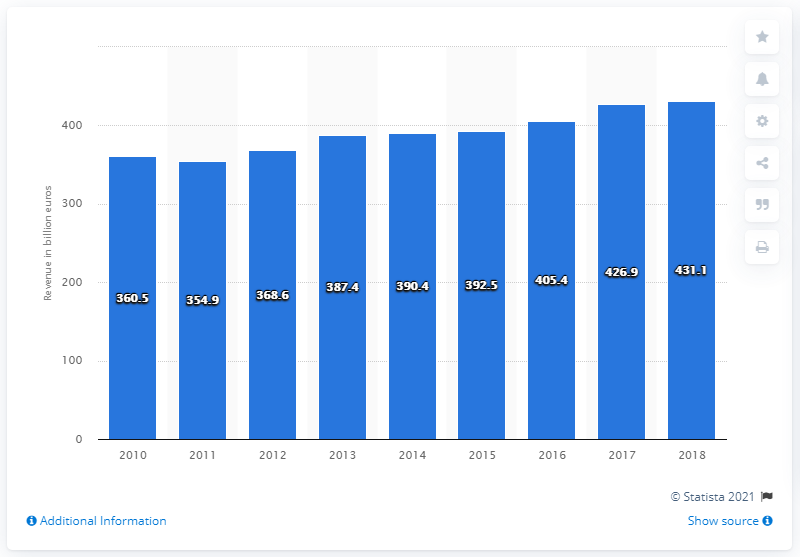Identify some key points in this picture. In 2011, the total public revenue was 354.9 million. The total public revenue in France in 2012 was 431.1 billion euros. In 2010, the total public revenue in France was 360.5 billion euros. 